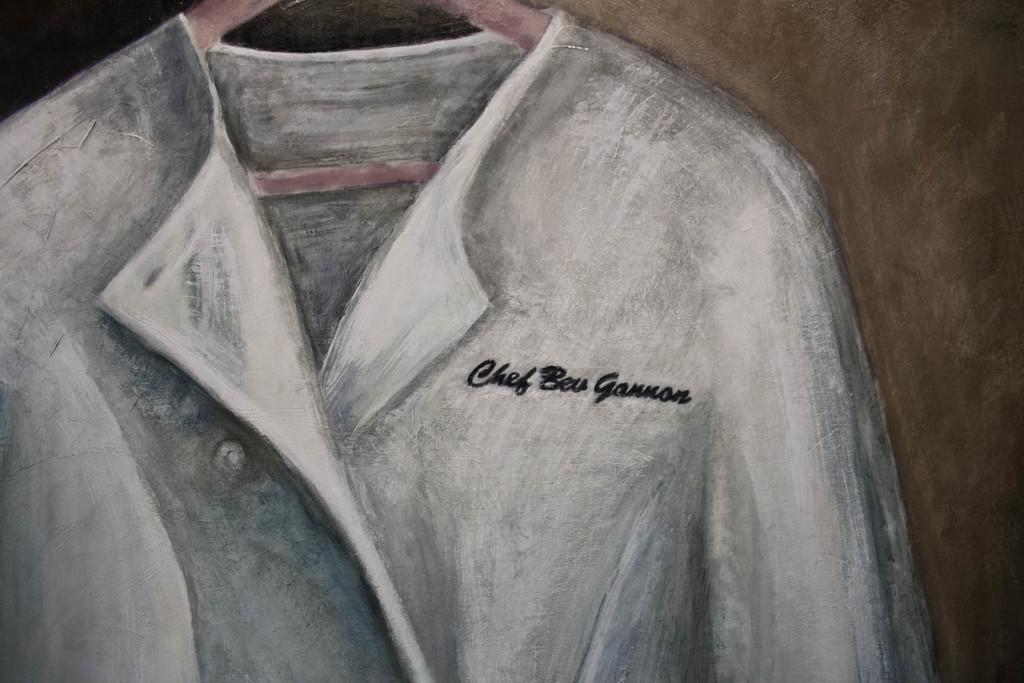What is the main subject of the image? There is a depiction of a picture in the image. What is featured in the picture? The picture contains a cloth. How is the cloth positioned in the picture? The cloth is on a hanger. Are there any words or letters in the image? Yes, there is text written in the image. What type of songs can be heard coming from the cherries in the image? There are no cherries present in the image, so it's not possible to determine what, if any, songs might be heard. 